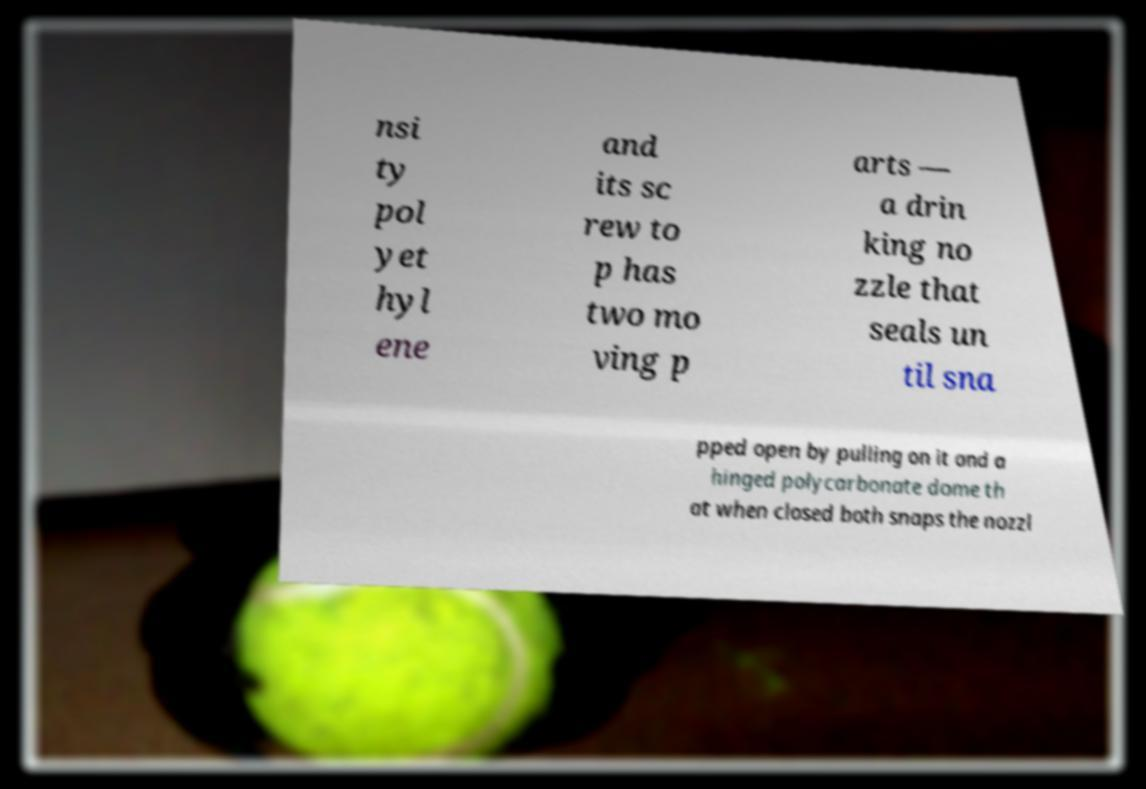Can you accurately transcribe the text from the provided image for me? nsi ty pol yet hyl ene and its sc rew to p has two mo ving p arts — a drin king no zzle that seals un til sna pped open by pulling on it and a hinged polycarbonate dome th at when closed both snaps the nozzl 